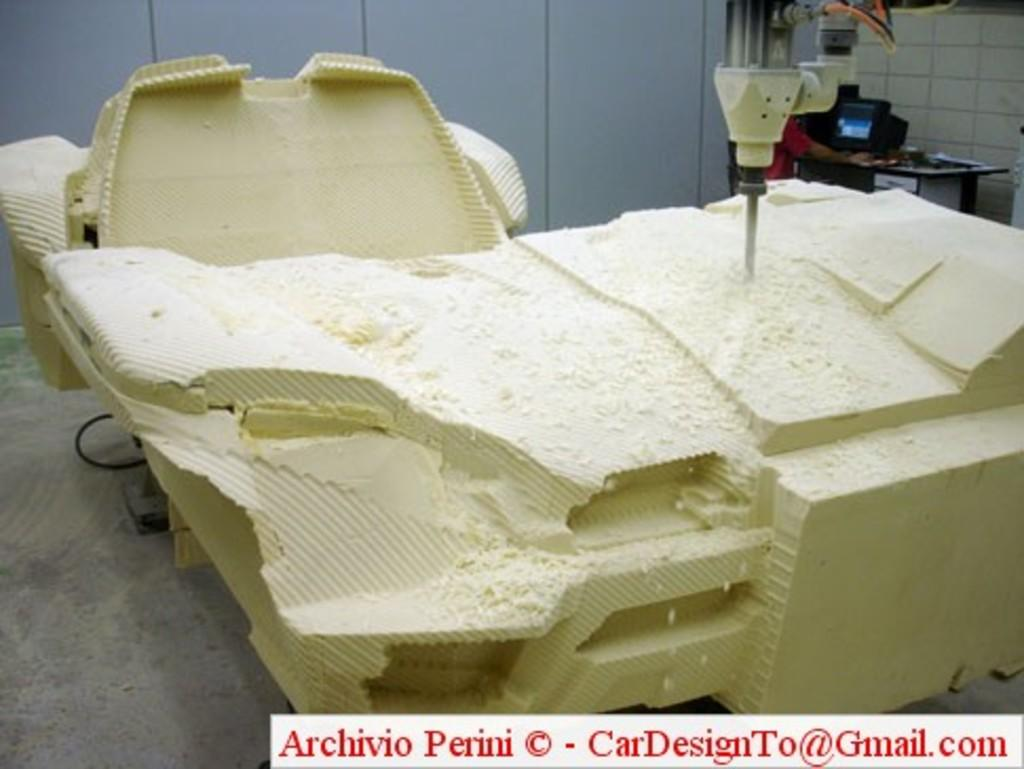What type of wooden item can be seen in the image? There is a wooden item in the image, but the specific type is not mentioned. What tool is present in the image? There is a drilling machine in the image. What electronic device is on a table in the image? There is a monitor on a table in the image. Can you describe the person in the image? There is a person in the image, but their appearance or actions are not mentioned. What additional feature is present on the image itself? There is a watermark on the image. Where is the drawer located in the image? There is no mention of a drawer in the image. What type of debt is being discussed in the image? There is no mention of debt in the image. 